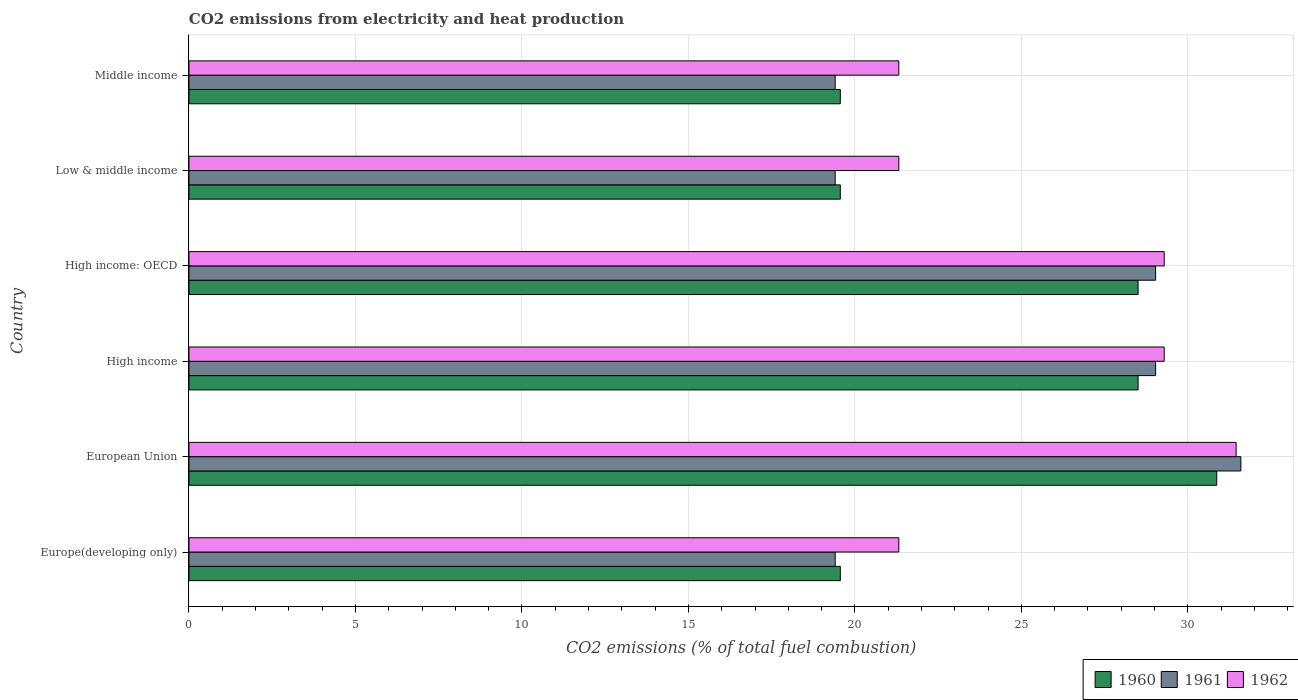How many different coloured bars are there?
Give a very brief answer. 3. How many groups of bars are there?
Give a very brief answer. 6. How many bars are there on the 6th tick from the top?
Offer a very short reply. 3. What is the label of the 3rd group of bars from the top?
Give a very brief answer. High income: OECD. In how many cases, is the number of bars for a given country not equal to the number of legend labels?
Offer a very short reply. 0. What is the amount of CO2 emitted in 1962 in Europe(developing only)?
Keep it short and to the point. 21.32. Across all countries, what is the maximum amount of CO2 emitted in 1962?
Ensure brevity in your answer.  31.45. Across all countries, what is the minimum amount of CO2 emitted in 1961?
Keep it short and to the point. 19.41. In which country was the amount of CO2 emitted in 1960 maximum?
Make the answer very short. European Union. In which country was the amount of CO2 emitted in 1962 minimum?
Your answer should be compact. Europe(developing only). What is the total amount of CO2 emitted in 1960 in the graph?
Provide a short and direct response. 146.57. What is the difference between the amount of CO2 emitted in 1961 in High income and the amount of CO2 emitted in 1960 in Low & middle income?
Offer a very short reply. 9.47. What is the average amount of CO2 emitted in 1962 per country?
Provide a succinct answer. 25.66. What is the difference between the amount of CO2 emitted in 1960 and amount of CO2 emitted in 1962 in Low & middle income?
Ensure brevity in your answer.  -1.76. What is the ratio of the amount of CO2 emitted in 1960 in European Union to that in Low & middle income?
Your response must be concise. 1.58. What is the difference between the highest and the second highest amount of CO2 emitted in 1961?
Your response must be concise. 2.56. What is the difference between the highest and the lowest amount of CO2 emitted in 1960?
Provide a short and direct response. 11.31. What does the 1st bar from the top in Low & middle income represents?
Offer a very short reply. 1962. What does the 3rd bar from the bottom in High income: OECD represents?
Provide a succinct answer. 1962. Are the values on the major ticks of X-axis written in scientific E-notation?
Offer a very short reply. No. Does the graph contain grids?
Your response must be concise. Yes. Where does the legend appear in the graph?
Keep it short and to the point. Bottom right. How are the legend labels stacked?
Offer a very short reply. Horizontal. What is the title of the graph?
Provide a succinct answer. CO2 emissions from electricity and heat production. Does "1967" appear as one of the legend labels in the graph?
Ensure brevity in your answer.  No. What is the label or title of the X-axis?
Provide a succinct answer. CO2 emissions (% of total fuel combustion). What is the label or title of the Y-axis?
Your response must be concise. Country. What is the CO2 emissions (% of total fuel combustion) in 1960 in Europe(developing only)?
Offer a very short reply. 19.56. What is the CO2 emissions (% of total fuel combustion) of 1961 in Europe(developing only)?
Offer a very short reply. 19.41. What is the CO2 emissions (% of total fuel combustion) of 1962 in Europe(developing only)?
Offer a very short reply. 21.32. What is the CO2 emissions (% of total fuel combustion) of 1960 in European Union?
Your response must be concise. 30.87. What is the CO2 emissions (% of total fuel combustion) in 1961 in European Union?
Your answer should be compact. 31.59. What is the CO2 emissions (% of total fuel combustion) in 1962 in European Union?
Your answer should be very brief. 31.45. What is the CO2 emissions (% of total fuel combustion) of 1960 in High income?
Give a very brief answer. 28.51. What is the CO2 emissions (% of total fuel combustion) in 1961 in High income?
Keep it short and to the point. 29.03. What is the CO2 emissions (% of total fuel combustion) in 1962 in High income?
Give a very brief answer. 29.29. What is the CO2 emissions (% of total fuel combustion) in 1960 in High income: OECD?
Your response must be concise. 28.51. What is the CO2 emissions (% of total fuel combustion) of 1961 in High income: OECD?
Provide a short and direct response. 29.03. What is the CO2 emissions (% of total fuel combustion) of 1962 in High income: OECD?
Your answer should be very brief. 29.29. What is the CO2 emissions (% of total fuel combustion) in 1960 in Low & middle income?
Offer a terse response. 19.56. What is the CO2 emissions (% of total fuel combustion) of 1961 in Low & middle income?
Ensure brevity in your answer.  19.41. What is the CO2 emissions (% of total fuel combustion) of 1962 in Low & middle income?
Give a very brief answer. 21.32. What is the CO2 emissions (% of total fuel combustion) of 1960 in Middle income?
Ensure brevity in your answer.  19.56. What is the CO2 emissions (% of total fuel combustion) of 1961 in Middle income?
Provide a succinct answer. 19.41. What is the CO2 emissions (% of total fuel combustion) in 1962 in Middle income?
Ensure brevity in your answer.  21.32. Across all countries, what is the maximum CO2 emissions (% of total fuel combustion) in 1960?
Offer a terse response. 30.87. Across all countries, what is the maximum CO2 emissions (% of total fuel combustion) of 1961?
Provide a succinct answer. 31.59. Across all countries, what is the maximum CO2 emissions (% of total fuel combustion) in 1962?
Provide a succinct answer. 31.45. Across all countries, what is the minimum CO2 emissions (% of total fuel combustion) in 1960?
Ensure brevity in your answer.  19.56. Across all countries, what is the minimum CO2 emissions (% of total fuel combustion) of 1961?
Make the answer very short. 19.41. Across all countries, what is the minimum CO2 emissions (% of total fuel combustion) in 1962?
Your answer should be very brief. 21.32. What is the total CO2 emissions (% of total fuel combustion) in 1960 in the graph?
Provide a short and direct response. 146.57. What is the total CO2 emissions (% of total fuel combustion) in 1961 in the graph?
Give a very brief answer. 147.88. What is the total CO2 emissions (% of total fuel combustion) of 1962 in the graph?
Offer a very short reply. 153.99. What is the difference between the CO2 emissions (% of total fuel combustion) in 1960 in Europe(developing only) and that in European Union?
Provide a short and direct response. -11.31. What is the difference between the CO2 emissions (% of total fuel combustion) in 1961 in Europe(developing only) and that in European Union?
Provide a short and direct response. -12.19. What is the difference between the CO2 emissions (% of total fuel combustion) of 1962 in Europe(developing only) and that in European Union?
Provide a short and direct response. -10.13. What is the difference between the CO2 emissions (% of total fuel combustion) of 1960 in Europe(developing only) and that in High income?
Offer a very short reply. -8.94. What is the difference between the CO2 emissions (% of total fuel combustion) in 1961 in Europe(developing only) and that in High income?
Give a very brief answer. -9.62. What is the difference between the CO2 emissions (% of total fuel combustion) in 1962 in Europe(developing only) and that in High income?
Provide a short and direct response. -7.97. What is the difference between the CO2 emissions (% of total fuel combustion) in 1960 in Europe(developing only) and that in High income: OECD?
Your answer should be very brief. -8.94. What is the difference between the CO2 emissions (% of total fuel combustion) of 1961 in Europe(developing only) and that in High income: OECD?
Offer a terse response. -9.62. What is the difference between the CO2 emissions (% of total fuel combustion) of 1962 in Europe(developing only) and that in High income: OECD?
Provide a short and direct response. -7.97. What is the difference between the CO2 emissions (% of total fuel combustion) of 1960 in Europe(developing only) and that in Low & middle income?
Provide a succinct answer. 0. What is the difference between the CO2 emissions (% of total fuel combustion) in 1962 in Europe(developing only) and that in Middle income?
Ensure brevity in your answer.  0. What is the difference between the CO2 emissions (% of total fuel combustion) of 1960 in European Union and that in High income?
Make the answer very short. 2.36. What is the difference between the CO2 emissions (% of total fuel combustion) of 1961 in European Union and that in High income?
Keep it short and to the point. 2.56. What is the difference between the CO2 emissions (% of total fuel combustion) in 1962 in European Union and that in High income?
Your response must be concise. 2.16. What is the difference between the CO2 emissions (% of total fuel combustion) in 1960 in European Union and that in High income: OECD?
Your response must be concise. 2.36. What is the difference between the CO2 emissions (% of total fuel combustion) of 1961 in European Union and that in High income: OECD?
Offer a terse response. 2.56. What is the difference between the CO2 emissions (% of total fuel combustion) in 1962 in European Union and that in High income: OECD?
Keep it short and to the point. 2.16. What is the difference between the CO2 emissions (% of total fuel combustion) of 1960 in European Union and that in Low & middle income?
Make the answer very short. 11.31. What is the difference between the CO2 emissions (% of total fuel combustion) of 1961 in European Union and that in Low & middle income?
Your response must be concise. 12.19. What is the difference between the CO2 emissions (% of total fuel combustion) of 1962 in European Union and that in Low & middle income?
Ensure brevity in your answer.  10.13. What is the difference between the CO2 emissions (% of total fuel combustion) of 1960 in European Union and that in Middle income?
Your answer should be compact. 11.31. What is the difference between the CO2 emissions (% of total fuel combustion) of 1961 in European Union and that in Middle income?
Keep it short and to the point. 12.19. What is the difference between the CO2 emissions (% of total fuel combustion) in 1962 in European Union and that in Middle income?
Keep it short and to the point. 10.13. What is the difference between the CO2 emissions (% of total fuel combustion) in 1962 in High income and that in High income: OECD?
Your response must be concise. 0. What is the difference between the CO2 emissions (% of total fuel combustion) of 1960 in High income and that in Low & middle income?
Keep it short and to the point. 8.94. What is the difference between the CO2 emissions (% of total fuel combustion) in 1961 in High income and that in Low & middle income?
Keep it short and to the point. 9.62. What is the difference between the CO2 emissions (% of total fuel combustion) in 1962 in High income and that in Low & middle income?
Provide a short and direct response. 7.97. What is the difference between the CO2 emissions (% of total fuel combustion) of 1960 in High income and that in Middle income?
Offer a very short reply. 8.94. What is the difference between the CO2 emissions (% of total fuel combustion) in 1961 in High income and that in Middle income?
Keep it short and to the point. 9.62. What is the difference between the CO2 emissions (% of total fuel combustion) of 1962 in High income and that in Middle income?
Your answer should be very brief. 7.97. What is the difference between the CO2 emissions (% of total fuel combustion) of 1960 in High income: OECD and that in Low & middle income?
Provide a short and direct response. 8.94. What is the difference between the CO2 emissions (% of total fuel combustion) in 1961 in High income: OECD and that in Low & middle income?
Your answer should be compact. 9.62. What is the difference between the CO2 emissions (% of total fuel combustion) of 1962 in High income: OECD and that in Low & middle income?
Ensure brevity in your answer.  7.97. What is the difference between the CO2 emissions (% of total fuel combustion) of 1960 in High income: OECD and that in Middle income?
Provide a short and direct response. 8.94. What is the difference between the CO2 emissions (% of total fuel combustion) in 1961 in High income: OECD and that in Middle income?
Keep it short and to the point. 9.62. What is the difference between the CO2 emissions (% of total fuel combustion) of 1962 in High income: OECD and that in Middle income?
Give a very brief answer. 7.97. What is the difference between the CO2 emissions (% of total fuel combustion) of 1960 in Europe(developing only) and the CO2 emissions (% of total fuel combustion) of 1961 in European Union?
Provide a succinct answer. -12.03. What is the difference between the CO2 emissions (% of total fuel combustion) of 1960 in Europe(developing only) and the CO2 emissions (% of total fuel combustion) of 1962 in European Union?
Offer a very short reply. -11.89. What is the difference between the CO2 emissions (% of total fuel combustion) in 1961 in Europe(developing only) and the CO2 emissions (% of total fuel combustion) in 1962 in European Union?
Keep it short and to the point. -12.04. What is the difference between the CO2 emissions (% of total fuel combustion) in 1960 in Europe(developing only) and the CO2 emissions (% of total fuel combustion) in 1961 in High income?
Ensure brevity in your answer.  -9.47. What is the difference between the CO2 emissions (% of total fuel combustion) of 1960 in Europe(developing only) and the CO2 emissions (% of total fuel combustion) of 1962 in High income?
Offer a terse response. -9.73. What is the difference between the CO2 emissions (% of total fuel combustion) of 1961 in Europe(developing only) and the CO2 emissions (% of total fuel combustion) of 1962 in High income?
Make the answer very short. -9.88. What is the difference between the CO2 emissions (% of total fuel combustion) of 1960 in Europe(developing only) and the CO2 emissions (% of total fuel combustion) of 1961 in High income: OECD?
Your answer should be compact. -9.47. What is the difference between the CO2 emissions (% of total fuel combustion) of 1960 in Europe(developing only) and the CO2 emissions (% of total fuel combustion) of 1962 in High income: OECD?
Give a very brief answer. -9.73. What is the difference between the CO2 emissions (% of total fuel combustion) of 1961 in Europe(developing only) and the CO2 emissions (% of total fuel combustion) of 1962 in High income: OECD?
Make the answer very short. -9.88. What is the difference between the CO2 emissions (% of total fuel combustion) of 1960 in Europe(developing only) and the CO2 emissions (% of total fuel combustion) of 1961 in Low & middle income?
Provide a succinct answer. 0.15. What is the difference between the CO2 emissions (% of total fuel combustion) of 1960 in Europe(developing only) and the CO2 emissions (% of total fuel combustion) of 1962 in Low & middle income?
Your answer should be very brief. -1.76. What is the difference between the CO2 emissions (% of total fuel combustion) of 1961 in Europe(developing only) and the CO2 emissions (% of total fuel combustion) of 1962 in Low & middle income?
Give a very brief answer. -1.91. What is the difference between the CO2 emissions (% of total fuel combustion) of 1960 in Europe(developing only) and the CO2 emissions (% of total fuel combustion) of 1961 in Middle income?
Give a very brief answer. 0.15. What is the difference between the CO2 emissions (% of total fuel combustion) in 1960 in Europe(developing only) and the CO2 emissions (% of total fuel combustion) in 1962 in Middle income?
Ensure brevity in your answer.  -1.76. What is the difference between the CO2 emissions (% of total fuel combustion) of 1961 in Europe(developing only) and the CO2 emissions (% of total fuel combustion) of 1962 in Middle income?
Offer a very short reply. -1.91. What is the difference between the CO2 emissions (% of total fuel combustion) in 1960 in European Union and the CO2 emissions (% of total fuel combustion) in 1961 in High income?
Your answer should be very brief. 1.84. What is the difference between the CO2 emissions (% of total fuel combustion) in 1960 in European Union and the CO2 emissions (% of total fuel combustion) in 1962 in High income?
Provide a short and direct response. 1.58. What is the difference between the CO2 emissions (% of total fuel combustion) of 1961 in European Union and the CO2 emissions (% of total fuel combustion) of 1962 in High income?
Provide a short and direct response. 2.3. What is the difference between the CO2 emissions (% of total fuel combustion) in 1960 in European Union and the CO2 emissions (% of total fuel combustion) in 1961 in High income: OECD?
Your answer should be compact. 1.84. What is the difference between the CO2 emissions (% of total fuel combustion) in 1960 in European Union and the CO2 emissions (% of total fuel combustion) in 1962 in High income: OECD?
Provide a succinct answer. 1.58. What is the difference between the CO2 emissions (% of total fuel combustion) of 1961 in European Union and the CO2 emissions (% of total fuel combustion) of 1962 in High income: OECD?
Your response must be concise. 2.3. What is the difference between the CO2 emissions (% of total fuel combustion) of 1960 in European Union and the CO2 emissions (% of total fuel combustion) of 1961 in Low & middle income?
Provide a succinct answer. 11.46. What is the difference between the CO2 emissions (% of total fuel combustion) of 1960 in European Union and the CO2 emissions (% of total fuel combustion) of 1962 in Low & middle income?
Provide a short and direct response. 9.55. What is the difference between the CO2 emissions (% of total fuel combustion) of 1961 in European Union and the CO2 emissions (% of total fuel combustion) of 1962 in Low & middle income?
Give a very brief answer. 10.27. What is the difference between the CO2 emissions (% of total fuel combustion) in 1960 in European Union and the CO2 emissions (% of total fuel combustion) in 1961 in Middle income?
Provide a succinct answer. 11.46. What is the difference between the CO2 emissions (% of total fuel combustion) of 1960 in European Union and the CO2 emissions (% of total fuel combustion) of 1962 in Middle income?
Ensure brevity in your answer.  9.55. What is the difference between the CO2 emissions (% of total fuel combustion) of 1961 in European Union and the CO2 emissions (% of total fuel combustion) of 1962 in Middle income?
Your answer should be compact. 10.27. What is the difference between the CO2 emissions (% of total fuel combustion) of 1960 in High income and the CO2 emissions (% of total fuel combustion) of 1961 in High income: OECD?
Your answer should be compact. -0.53. What is the difference between the CO2 emissions (% of total fuel combustion) in 1960 in High income and the CO2 emissions (% of total fuel combustion) in 1962 in High income: OECD?
Make the answer very short. -0.78. What is the difference between the CO2 emissions (% of total fuel combustion) of 1961 in High income and the CO2 emissions (% of total fuel combustion) of 1962 in High income: OECD?
Ensure brevity in your answer.  -0.26. What is the difference between the CO2 emissions (% of total fuel combustion) in 1960 in High income and the CO2 emissions (% of total fuel combustion) in 1961 in Low & middle income?
Offer a terse response. 9.1. What is the difference between the CO2 emissions (% of total fuel combustion) in 1960 in High income and the CO2 emissions (% of total fuel combustion) in 1962 in Low & middle income?
Keep it short and to the point. 7.19. What is the difference between the CO2 emissions (% of total fuel combustion) of 1961 in High income and the CO2 emissions (% of total fuel combustion) of 1962 in Low & middle income?
Your answer should be very brief. 7.71. What is the difference between the CO2 emissions (% of total fuel combustion) in 1960 in High income and the CO2 emissions (% of total fuel combustion) in 1961 in Middle income?
Your answer should be very brief. 9.1. What is the difference between the CO2 emissions (% of total fuel combustion) of 1960 in High income and the CO2 emissions (% of total fuel combustion) of 1962 in Middle income?
Offer a very short reply. 7.19. What is the difference between the CO2 emissions (% of total fuel combustion) in 1961 in High income and the CO2 emissions (% of total fuel combustion) in 1962 in Middle income?
Provide a short and direct response. 7.71. What is the difference between the CO2 emissions (% of total fuel combustion) of 1960 in High income: OECD and the CO2 emissions (% of total fuel combustion) of 1961 in Low & middle income?
Ensure brevity in your answer.  9.1. What is the difference between the CO2 emissions (% of total fuel combustion) in 1960 in High income: OECD and the CO2 emissions (% of total fuel combustion) in 1962 in Low & middle income?
Your response must be concise. 7.19. What is the difference between the CO2 emissions (% of total fuel combustion) in 1961 in High income: OECD and the CO2 emissions (% of total fuel combustion) in 1962 in Low & middle income?
Provide a succinct answer. 7.71. What is the difference between the CO2 emissions (% of total fuel combustion) of 1960 in High income: OECD and the CO2 emissions (% of total fuel combustion) of 1961 in Middle income?
Your response must be concise. 9.1. What is the difference between the CO2 emissions (% of total fuel combustion) in 1960 in High income: OECD and the CO2 emissions (% of total fuel combustion) in 1962 in Middle income?
Make the answer very short. 7.19. What is the difference between the CO2 emissions (% of total fuel combustion) of 1961 in High income: OECD and the CO2 emissions (% of total fuel combustion) of 1962 in Middle income?
Provide a short and direct response. 7.71. What is the difference between the CO2 emissions (% of total fuel combustion) of 1960 in Low & middle income and the CO2 emissions (% of total fuel combustion) of 1961 in Middle income?
Offer a very short reply. 0.15. What is the difference between the CO2 emissions (% of total fuel combustion) of 1960 in Low & middle income and the CO2 emissions (% of total fuel combustion) of 1962 in Middle income?
Your answer should be compact. -1.76. What is the difference between the CO2 emissions (% of total fuel combustion) in 1961 in Low & middle income and the CO2 emissions (% of total fuel combustion) in 1962 in Middle income?
Your answer should be compact. -1.91. What is the average CO2 emissions (% of total fuel combustion) in 1960 per country?
Make the answer very short. 24.43. What is the average CO2 emissions (% of total fuel combustion) in 1961 per country?
Offer a terse response. 24.65. What is the average CO2 emissions (% of total fuel combustion) of 1962 per country?
Offer a terse response. 25.66. What is the difference between the CO2 emissions (% of total fuel combustion) in 1960 and CO2 emissions (% of total fuel combustion) in 1961 in Europe(developing only)?
Ensure brevity in your answer.  0.15. What is the difference between the CO2 emissions (% of total fuel combustion) in 1960 and CO2 emissions (% of total fuel combustion) in 1962 in Europe(developing only)?
Ensure brevity in your answer.  -1.76. What is the difference between the CO2 emissions (% of total fuel combustion) of 1961 and CO2 emissions (% of total fuel combustion) of 1962 in Europe(developing only)?
Your answer should be compact. -1.91. What is the difference between the CO2 emissions (% of total fuel combustion) of 1960 and CO2 emissions (% of total fuel combustion) of 1961 in European Union?
Keep it short and to the point. -0.73. What is the difference between the CO2 emissions (% of total fuel combustion) of 1960 and CO2 emissions (% of total fuel combustion) of 1962 in European Union?
Keep it short and to the point. -0.58. What is the difference between the CO2 emissions (% of total fuel combustion) of 1961 and CO2 emissions (% of total fuel combustion) of 1962 in European Union?
Your response must be concise. 0.14. What is the difference between the CO2 emissions (% of total fuel combustion) of 1960 and CO2 emissions (% of total fuel combustion) of 1961 in High income?
Offer a terse response. -0.53. What is the difference between the CO2 emissions (% of total fuel combustion) in 1960 and CO2 emissions (% of total fuel combustion) in 1962 in High income?
Keep it short and to the point. -0.78. What is the difference between the CO2 emissions (% of total fuel combustion) of 1961 and CO2 emissions (% of total fuel combustion) of 1962 in High income?
Offer a very short reply. -0.26. What is the difference between the CO2 emissions (% of total fuel combustion) of 1960 and CO2 emissions (% of total fuel combustion) of 1961 in High income: OECD?
Ensure brevity in your answer.  -0.53. What is the difference between the CO2 emissions (% of total fuel combustion) in 1960 and CO2 emissions (% of total fuel combustion) in 1962 in High income: OECD?
Offer a terse response. -0.78. What is the difference between the CO2 emissions (% of total fuel combustion) in 1961 and CO2 emissions (% of total fuel combustion) in 1962 in High income: OECD?
Your answer should be very brief. -0.26. What is the difference between the CO2 emissions (% of total fuel combustion) of 1960 and CO2 emissions (% of total fuel combustion) of 1961 in Low & middle income?
Ensure brevity in your answer.  0.15. What is the difference between the CO2 emissions (% of total fuel combustion) in 1960 and CO2 emissions (% of total fuel combustion) in 1962 in Low & middle income?
Your answer should be compact. -1.76. What is the difference between the CO2 emissions (% of total fuel combustion) in 1961 and CO2 emissions (% of total fuel combustion) in 1962 in Low & middle income?
Keep it short and to the point. -1.91. What is the difference between the CO2 emissions (% of total fuel combustion) in 1960 and CO2 emissions (% of total fuel combustion) in 1961 in Middle income?
Provide a short and direct response. 0.15. What is the difference between the CO2 emissions (% of total fuel combustion) of 1960 and CO2 emissions (% of total fuel combustion) of 1962 in Middle income?
Ensure brevity in your answer.  -1.76. What is the difference between the CO2 emissions (% of total fuel combustion) in 1961 and CO2 emissions (% of total fuel combustion) in 1962 in Middle income?
Your response must be concise. -1.91. What is the ratio of the CO2 emissions (% of total fuel combustion) in 1960 in Europe(developing only) to that in European Union?
Provide a succinct answer. 0.63. What is the ratio of the CO2 emissions (% of total fuel combustion) in 1961 in Europe(developing only) to that in European Union?
Offer a terse response. 0.61. What is the ratio of the CO2 emissions (% of total fuel combustion) of 1962 in Europe(developing only) to that in European Union?
Your answer should be compact. 0.68. What is the ratio of the CO2 emissions (% of total fuel combustion) in 1960 in Europe(developing only) to that in High income?
Make the answer very short. 0.69. What is the ratio of the CO2 emissions (% of total fuel combustion) of 1961 in Europe(developing only) to that in High income?
Provide a succinct answer. 0.67. What is the ratio of the CO2 emissions (% of total fuel combustion) in 1962 in Europe(developing only) to that in High income?
Provide a succinct answer. 0.73. What is the ratio of the CO2 emissions (% of total fuel combustion) in 1960 in Europe(developing only) to that in High income: OECD?
Make the answer very short. 0.69. What is the ratio of the CO2 emissions (% of total fuel combustion) in 1961 in Europe(developing only) to that in High income: OECD?
Your response must be concise. 0.67. What is the ratio of the CO2 emissions (% of total fuel combustion) of 1962 in Europe(developing only) to that in High income: OECD?
Ensure brevity in your answer.  0.73. What is the ratio of the CO2 emissions (% of total fuel combustion) in 1960 in Europe(developing only) to that in Middle income?
Make the answer very short. 1. What is the ratio of the CO2 emissions (% of total fuel combustion) in 1961 in Europe(developing only) to that in Middle income?
Your response must be concise. 1. What is the ratio of the CO2 emissions (% of total fuel combustion) in 1962 in Europe(developing only) to that in Middle income?
Your response must be concise. 1. What is the ratio of the CO2 emissions (% of total fuel combustion) of 1960 in European Union to that in High income?
Keep it short and to the point. 1.08. What is the ratio of the CO2 emissions (% of total fuel combustion) in 1961 in European Union to that in High income?
Offer a terse response. 1.09. What is the ratio of the CO2 emissions (% of total fuel combustion) of 1962 in European Union to that in High income?
Your answer should be very brief. 1.07. What is the ratio of the CO2 emissions (% of total fuel combustion) of 1960 in European Union to that in High income: OECD?
Give a very brief answer. 1.08. What is the ratio of the CO2 emissions (% of total fuel combustion) of 1961 in European Union to that in High income: OECD?
Your answer should be compact. 1.09. What is the ratio of the CO2 emissions (% of total fuel combustion) in 1962 in European Union to that in High income: OECD?
Give a very brief answer. 1.07. What is the ratio of the CO2 emissions (% of total fuel combustion) in 1960 in European Union to that in Low & middle income?
Your answer should be compact. 1.58. What is the ratio of the CO2 emissions (% of total fuel combustion) of 1961 in European Union to that in Low & middle income?
Your answer should be very brief. 1.63. What is the ratio of the CO2 emissions (% of total fuel combustion) of 1962 in European Union to that in Low & middle income?
Offer a very short reply. 1.48. What is the ratio of the CO2 emissions (% of total fuel combustion) in 1960 in European Union to that in Middle income?
Keep it short and to the point. 1.58. What is the ratio of the CO2 emissions (% of total fuel combustion) in 1961 in European Union to that in Middle income?
Make the answer very short. 1.63. What is the ratio of the CO2 emissions (% of total fuel combustion) of 1962 in European Union to that in Middle income?
Your answer should be very brief. 1.48. What is the ratio of the CO2 emissions (% of total fuel combustion) in 1960 in High income to that in High income: OECD?
Your response must be concise. 1. What is the ratio of the CO2 emissions (% of total fuel combustion) of 1960 in High income to that in Low & middle income?
Your response must be concise. 1.46. What is the ratio of the CO2 emissions (% of total fuel combustion) of 1961 in High income to that in Low & middle income?
Your answer should be compact. 1.5. What is the ratio of the CO2 emissions (% of total fuel combustion) in 1962 in High income to that in Low & middle income?
Ensure brevity in your answer.  1.37. What is the ratio of the CO2 emissions (% of total fuel combustion) in 1960 in High income to that in Middle income?
Your response must be concise. 1.46. What is the ratio of the CO2 emissions (% of total fuel combustion) of 1961 in High income to that in Middle income?
Offer a very short reply. 1.5. What is the ratio of the CO2 emissions (% of total fuel combustion) of 1962 in High income to that in Middle income?
Ensure brevity in your answer.  1.37. What is the ratio of the CO2 emissions (% of total fuel combustion) of 1960 in High income: OECD to that in Low & middle income?
Ensure brevity in your answer.  1.46. What is the ratio of the CO2 emissions (% of total fuel combustion) in 1961 in High income: OECD to that in Low & middle income?
Offer a very short reply. 1.5. What is the ratio of the CO2 emissions (% of total fuel combustion) in 1962 in High income: OECD to that in Low & middle income?
Your answer should be very brief. 1.37. What is the ratio of the CO2 emissions (% of total fuel combustion) in 1960 in High income: OECD to that in Middle income?
Keep it short and to the point. 1.46. What is the ratio of the CO2 emissions (% of total fuel combustion) of 1961 in High income: OECD to that in Middle income?
Your answer should be very brief. 1.5. What is the ratio of the CO2 emissions (% of total fuel combustion) in 1962 in High income: OECD to that in Middle income?
Provide a succinct answer. 1.37. What is the ratio of the CO2 emissions (% of total fuel combustion) of 1960 in Low & middle income to that in Middle income?
Provide a succinct answer. 1. What is the ratio of the CO2 emissions (% of total fuel combustion) in 1962 in Low & middle income to that in Middle income?
Your answer should be very brief. 1. What is the difference between the highest and the second highest CO2 emissions (% of total fuel combustion) in 1960?
Your answer should be very brief. 2.36. What is the difference between the highest and the second highest CO2 emissions (% of total fuel combustion) in 1961?
Make the answer very short. 2.56. What is the difference between the highest and the second highest CO2 emissions (% of total fuel combustion) in 1962?
Your answer should be compact. 2.16. What is the difference between the highest and the lowest CO2 emissions (% of total fuel combustion) of 1960?
Offer a terse response. 11.31. What is the difference between the highest and the lowest CO2 emissions (% of total fuel combustion) in 1961?
Your answer should be very brief. 12.19. What is the difference between the highest and the lowest CO2 emissions (% of total fuel combustion) of 1962?
Offer a very short reply. 10.13. 